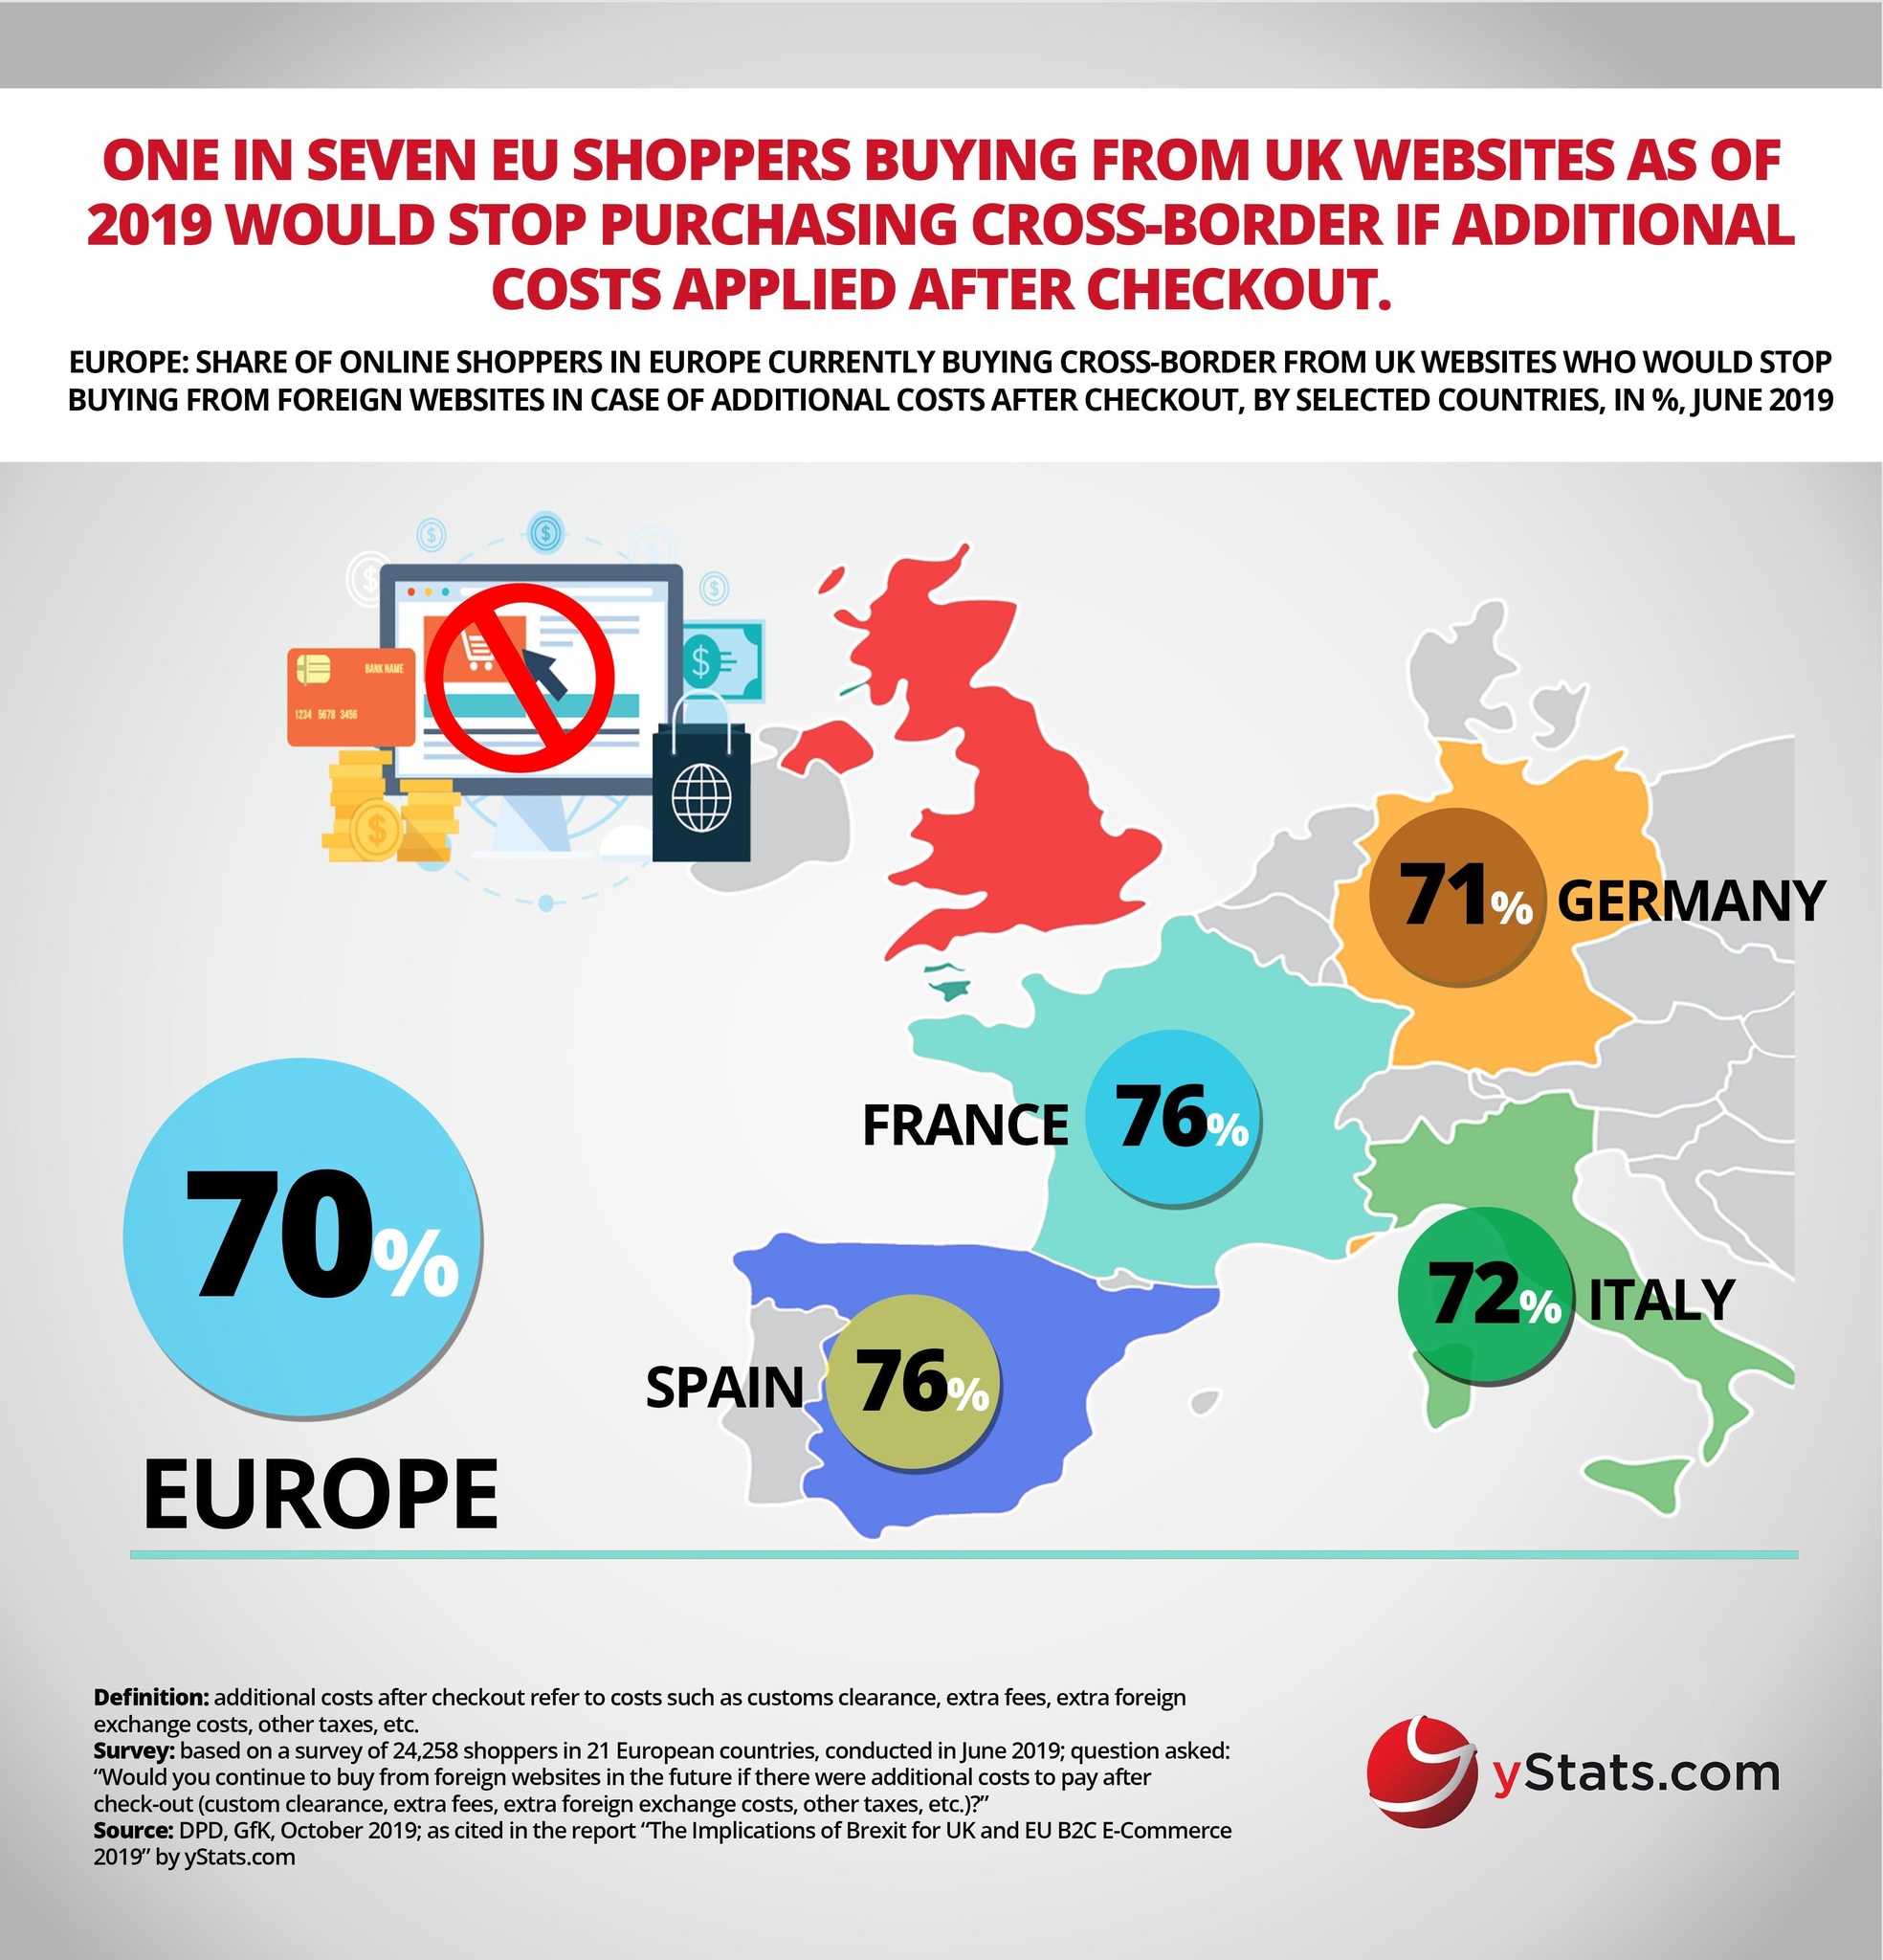how many of shoppers from Spain would stop buying from UK websites if additional charges are applied?
Answer the question with a short phrase. 76% 71% of shoppers from which European country would stop buying from UK websites if additional charges are applied? Germany 72% of shoppers from which European country would stop buying from UK websites if additional charges are applied? Italy how many of French shoppers would stop buying from UK websites if additional charges are applied? 76% 